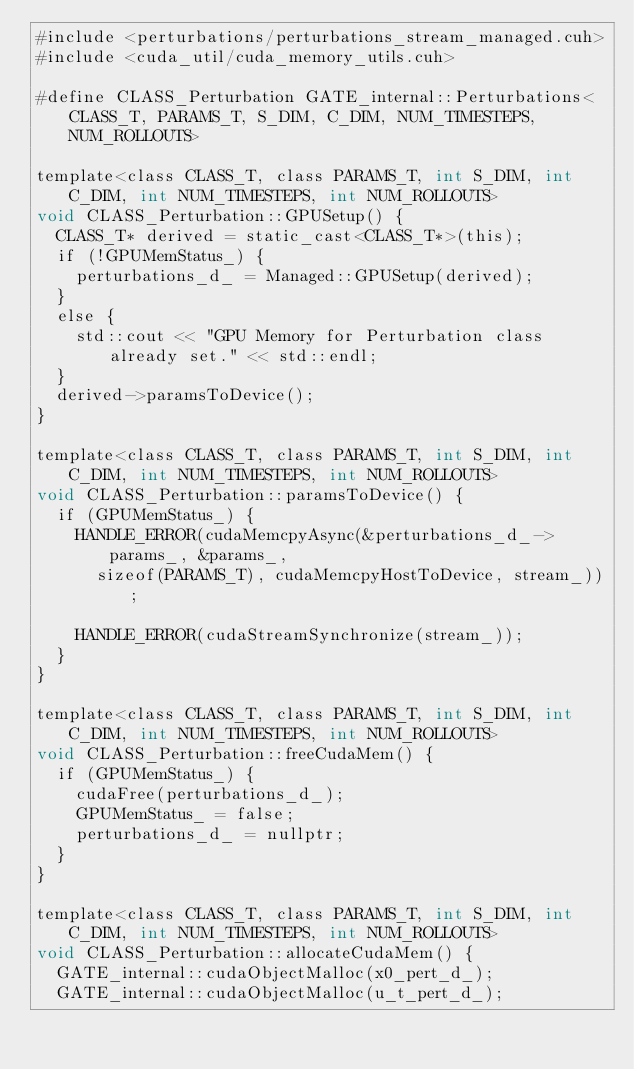Convert code to text. <code><loc_0><loc_0><loc_500><loc_500><_Cuda_>#include <perturbations/perturbations_stream_managed.cuh>
#include <cuda_util/cuda_memory_utils.cuh>

#define CLASS_Perturbation GATE_internal::Perturbations<CLASS_T, PARAMS_T, S_DIM, C_DIM, NUM_TIMESTEPS, NUM_ROLLOUTS>

template<class CLASS_T, class PARAMS_T, int S_DIM, int C_DIM, int NUM_TIMESTEPS, int NUM_ROLLOUTS>
void CLASS_Perturbation::GPUSetup() {
	CLASS_T* derived = static_cast<CLASS_T*>(this);
	if (!GPUMemStatus_) {
		perturbations_d_ = Managed::GPUSetup(derived);
	}
	else {
		std::cout << "GPU Memory for Perturbation class already set." << std::endl;
	}
	derived->paramsToDevice();
}

template<class CLASS_T, class PARAMS_T, int S_DIM, int C_DIM, int NUM_TIMESTEPS, int NUM_ROLLOUTS>
void CLASS_Perturbation::paramsToDevice() {
	if (GPUMemStatus_) {
		HANDLE_ERROR(cudaMemcpyAsync(&perturbations_d_->params_, &params_,
			sizeof(PARAMS_T), cudaMemcpyHostToDevice, stream_));

		HANDLE_ERROR(cudaStreamSynchronize(stream_));
	}
}

template<class CLASS_T, class PARAMS_T, int S_DIM, int C_DIM, int NUM_TIMESTEPS, int NUM_ROLLOUTS>
void CLASS_Perturbation::freeCudaMem() {
	if (GPUMemStatus_) {
		cudaFree(perturbations_d_);
		GPUMemStatus_ = false;
		perturbations_d_ = nullptr;
	}
}

template<class CLASS_T, class PARAMS_T, int S_DIM, int C_DIM, int NUM_TIMESTEPS, int NUM_ROLLOUTS>
void CLASS_Perturbation::allocateCudaMem() {
	GATE_internal::cudaObjectMalloc(x0_pert_d_);
	GATE_internal::cudaObjectMalloc(u_t_pert_d_);</code> 